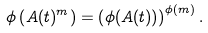<formula> <loc_0><loc_0><loc_500><loc_500>\phi \left ( A ( t ) ^ { m } \right ) = \left ( \phi ( A ( t ) ) \right ) ^ { \phi ( m ) } .</formula> 